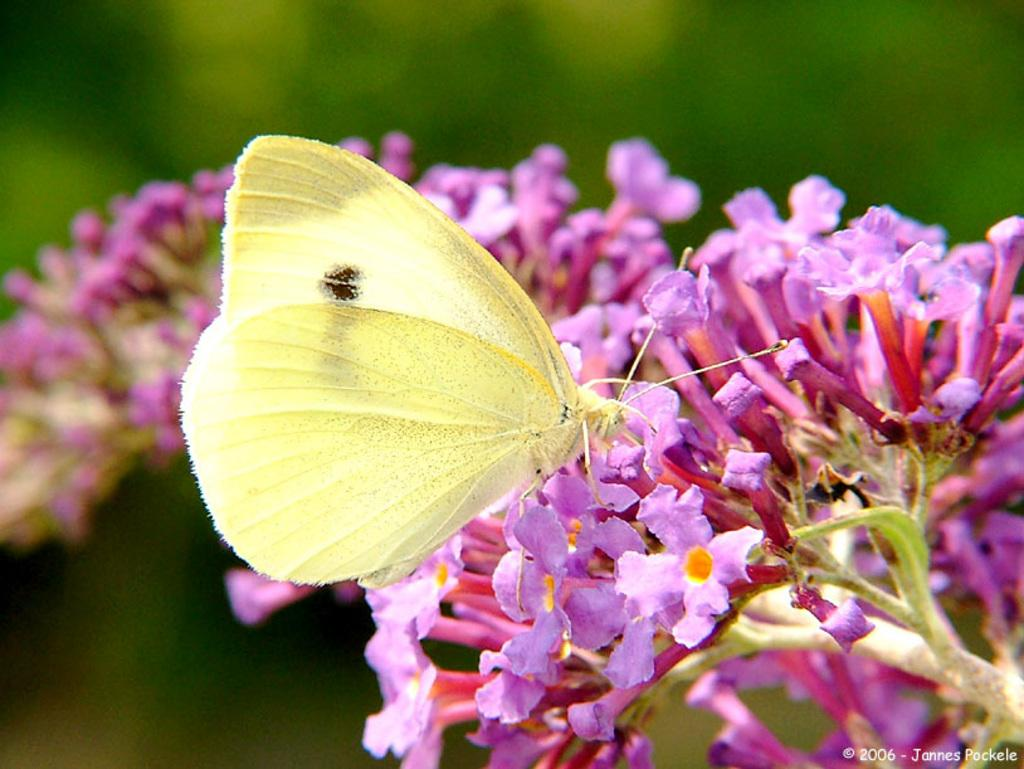What is the main subject of the image? There is a butterfly in the image. What is the butterfly standing on? The butterfly is standing on purple flowers. Can you describe the background of the image? The background of the image is blurry. What type of harmony is being played by the butterfly on the canvas in the image? There is no canvas or harmony present in the image; it features a butterfly standing on purple flowers with a blurry background. 